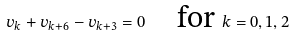<formula> <loc_0><loc_0><loc_500><loc_500>v _ { k } + v _ { k + 6 } - v _ { k + 3 } = 0 \quad \text {for } k = 0 , 1 , 2</formula> 